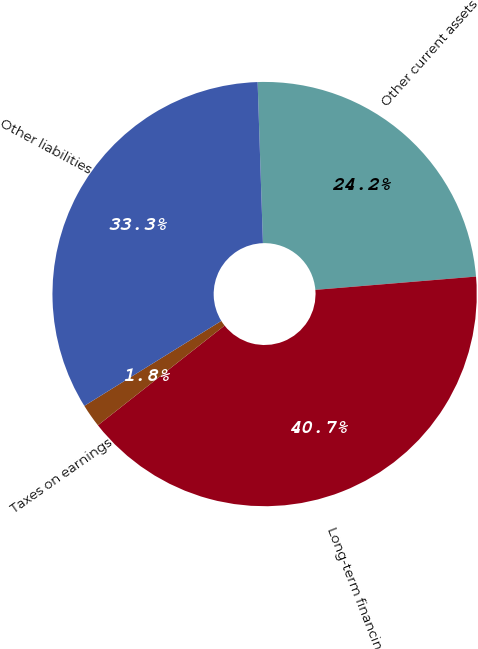<chart> <loc_0><loc_0><loc_500><loc_500><pie_chart><fcel>Other current assets<fcel>Long-term financing<fcel>Taxes on earnings<fcel>Other liabilities<nl><fcel>24.21%<fcel>40.7%<fcel>1.78%<fcel>33.31%<nl></chart> 